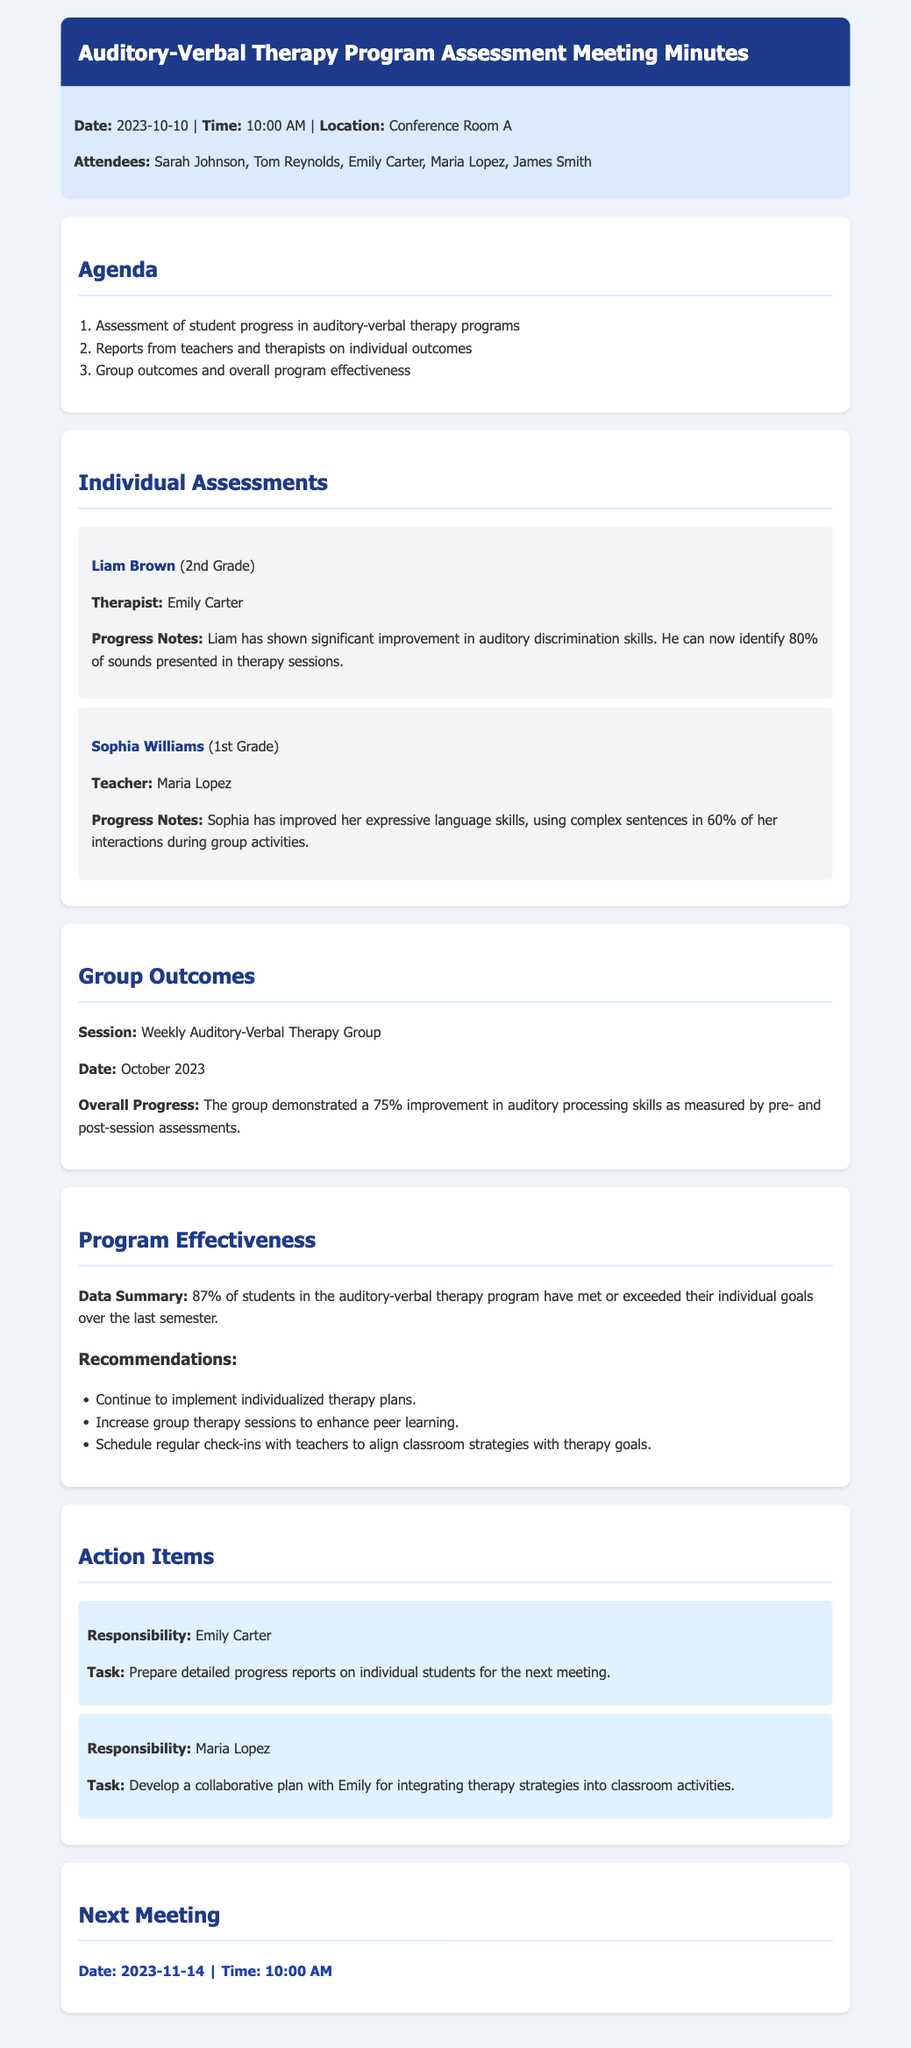What is the date of the meeting? The date of the meeting is mentioned at the beginning of the document.
Answer: 2023-10-10 Who is the therapist for Liam Brown? The document provides the name of the therapist associated with Liam's assessment.
Answer: Emily Carter What percentage of students met or exceeded their individual goals? The document summarizes the overall performance of students in the program.
Answer: 87% What improvement percentage did the group achieve in auditory processing skills? The document details the group's overall progress based on assessments.
Answer: 75% What is Sophia Williams's grade? The document specifies the grade level for each student mentioned.
Answer: 1st Grade What task is assigned to Emily Carter? The action items section includes tasks assigned to individuals after the meeting.
Answer: Prepare detailed progress reports on individual students for the next meeting Which session is mentioned in the group outcomes? The document specifies the type of session being reported in the group outcomes.
Answer: Weekly Auditory-Verbal Therapy Group What recommendation is made regarding group therapy sessions? The document provides recommendations based on the program's effectiveness.
Answer: Increase group therapy sessions to enhance peer learning When is the next meeting scheduled? The document indicates the date and time for the next meeting at the end.
Answer: 2023-11-14 